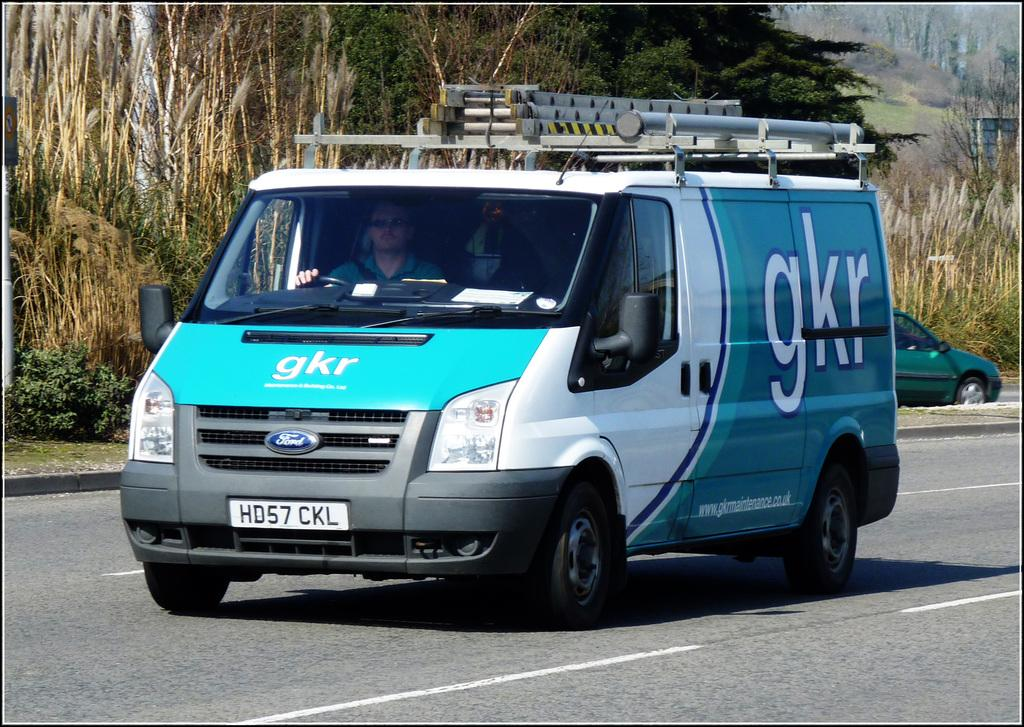<image>
Describe the image concisely. A white and blue van with gkr printed on its side. 